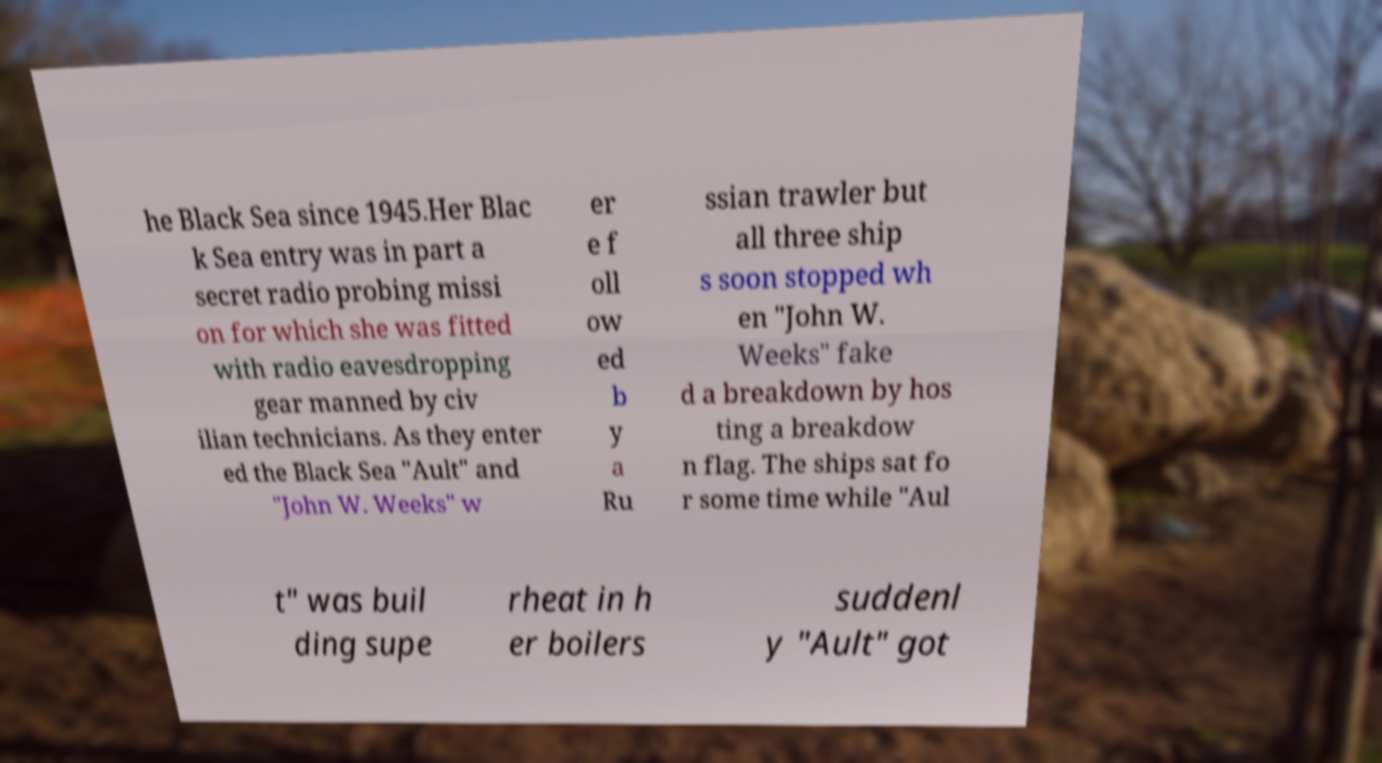Could you assist in decoding the text presented in this image and type it out clearly? he Black Sea since 1945.Her Blac k Sea entry was in part a secret radio probing missi on for which she was fitted with radio eavesdropping gear manned by civ ilian technicians. As they enter ed the Black Sea "Ault" and "John W. Weeks" w er e f oll ow ed b y a Ru ssian trawler but all three ship s soon stopped wh en "John W. Weeks" fake d a breakdown by hos ting a breakdow n flag. The ships sat fo r some time while "Aul t" was buil ding supe rheat in h er boilers suddenl y "Ault" got 